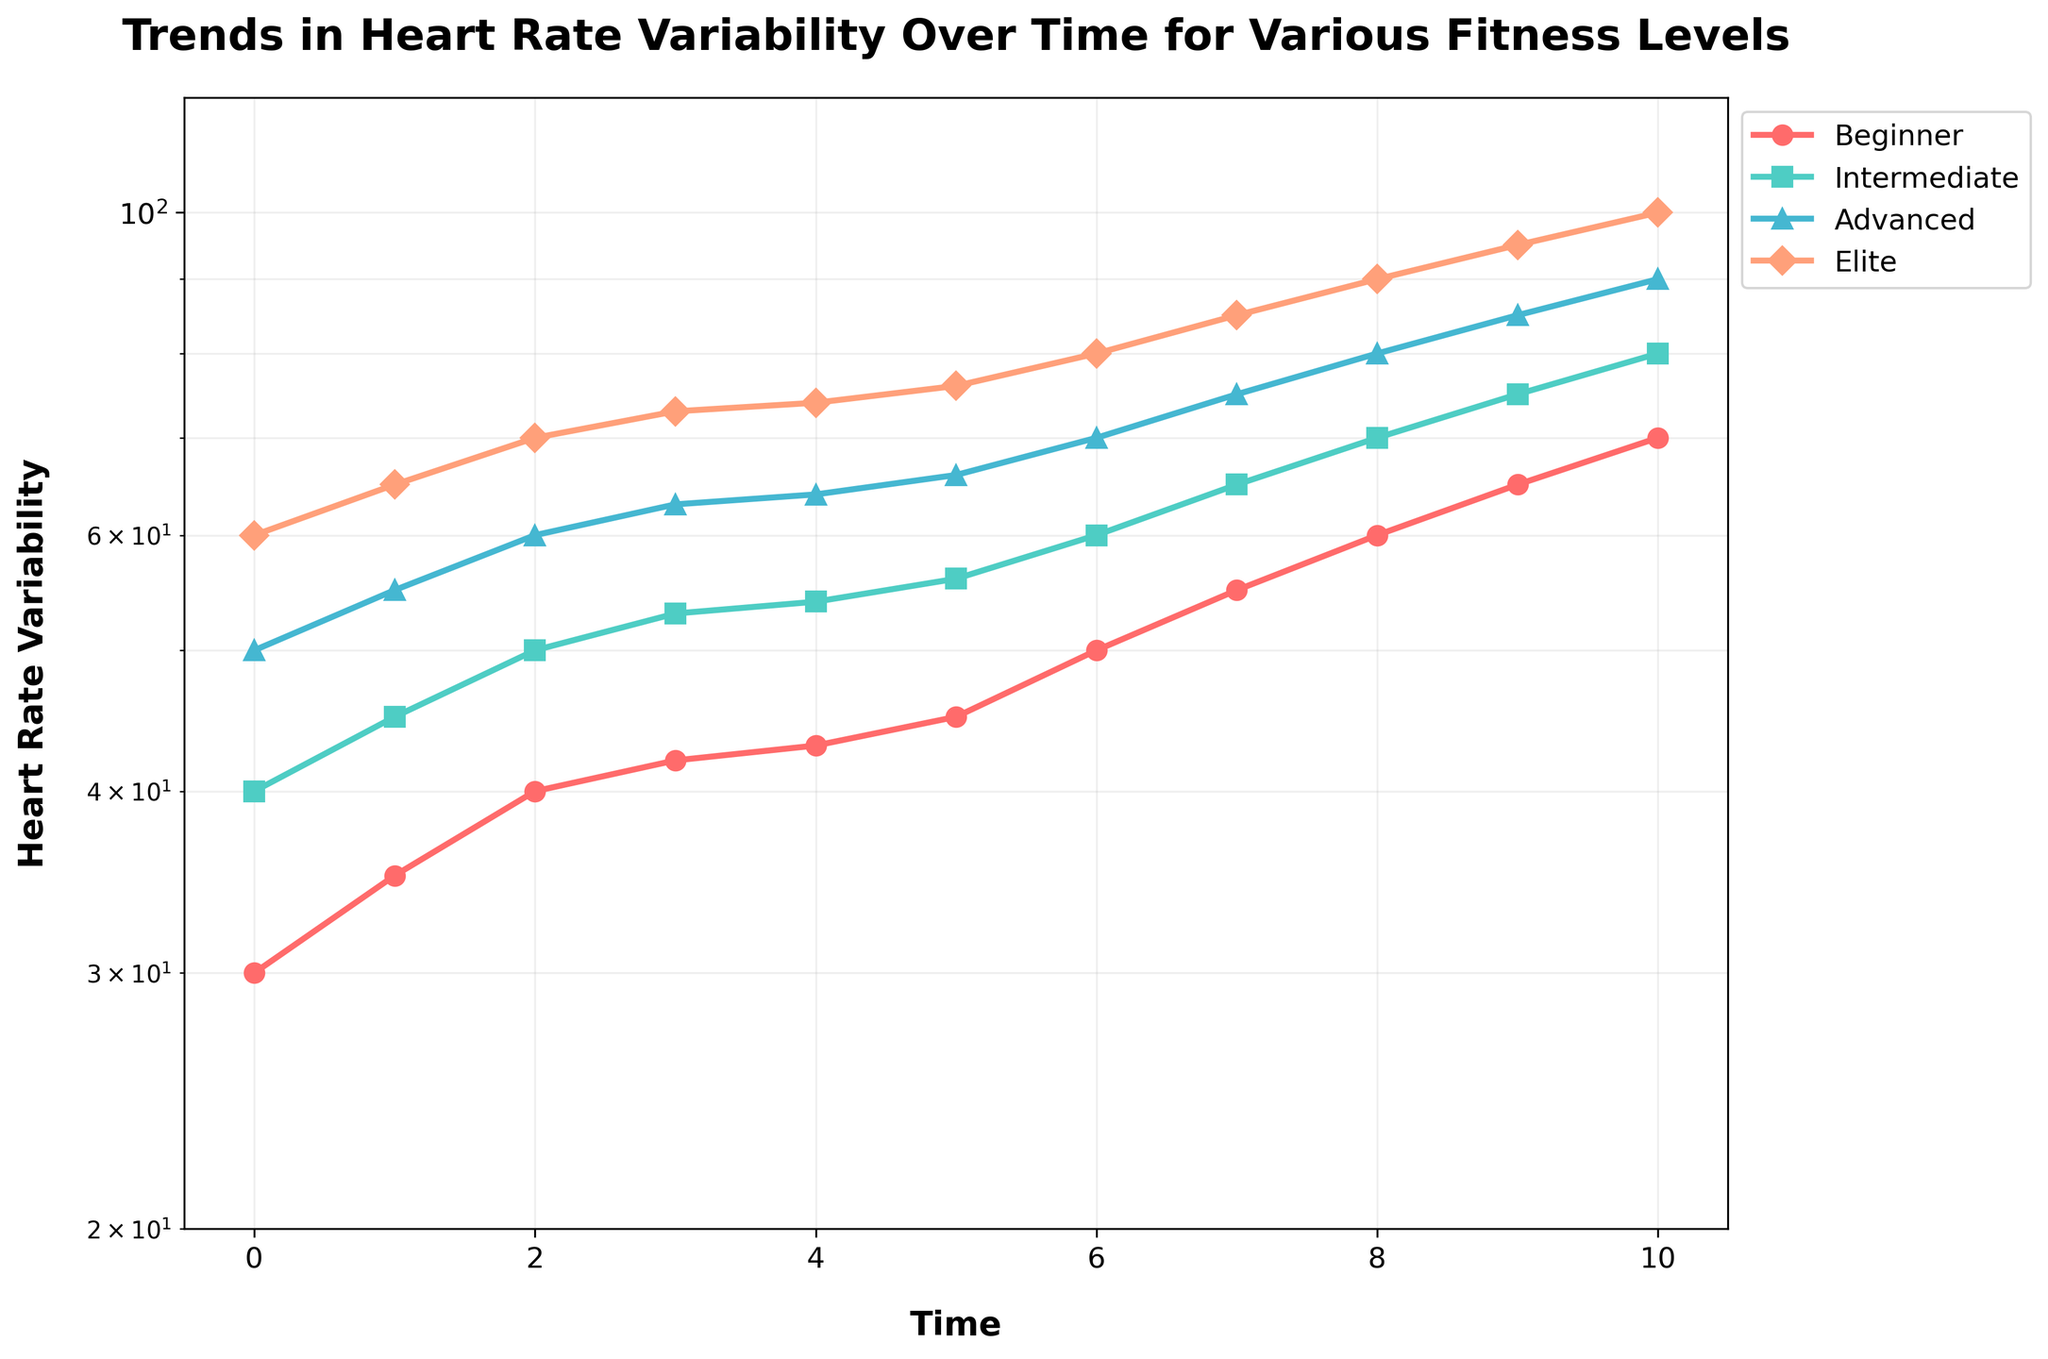What's the title of the plot? The title is displayed at the top of the plot and it provides the main subject of the data being visualized.
Answer: Trends in Heart Rate Variability Over Time for Various Fitness Levels Which fitness level has the highest heart rate variability at time = 0? By looking at the points plotted on the graph at time = 0, we can identify that the Elite fitness level has the highest value.
Answer: Elite What is the heart rate variability of the Intermediate group at time = 5? Find the time = 5 on the x-axis and then move up vertically to the Intermediate group's line, then read the corresponding value on the y-axis.
Answer: 56 What is the rate of change in heart rate variability for the Beginner group between time = 6 and time = 8? Calculate the difference in heart rate variability at time = 8 and time = 6, then divide by the time interval. From time = 6 to 8, the Beginner group goes from 50 to 60. Rate of change = (60 - 50) / (8 - 6).
Answer: 5 Which group's heart rate variability increased the fastest from time = 0 to time = 10? Compare the differences between the values at time = 10 and time = 0 for all groups. The Elite group increased from 60 to 100, which is the highest absolute increase.
Answer: Elite How many different fitness levels are shown in the plot? Count the number of different labeled lines in the legend.
Answer: 4 What does the y-axis represent? Read the label of the y-axis on the plot.
Answer: Heart Rate Variability Which fitness level shows the most stability (smallest variability increase) in heart rate variability over the time period? Evaluate the changes in heart rate variability for each group from time = 0 to time = 10 and find the one with the smallest increase. The Beginner group went from 30 to 70, which shows less variability change compared to others.
Answer: Beginner Does the graph utilize a linear or logarithmic scale? Observe the scaling of the y-axis. The axis labels and spacing indicate that it's a logarithmic scale.
Answer: Logarithmic Which group shows a consistently upward trend in heart rate variability over time? Observe the lines for each group and check if they continuously increase without falling. All groups demonstrate a consistent upward trend.
Answer: All groups 